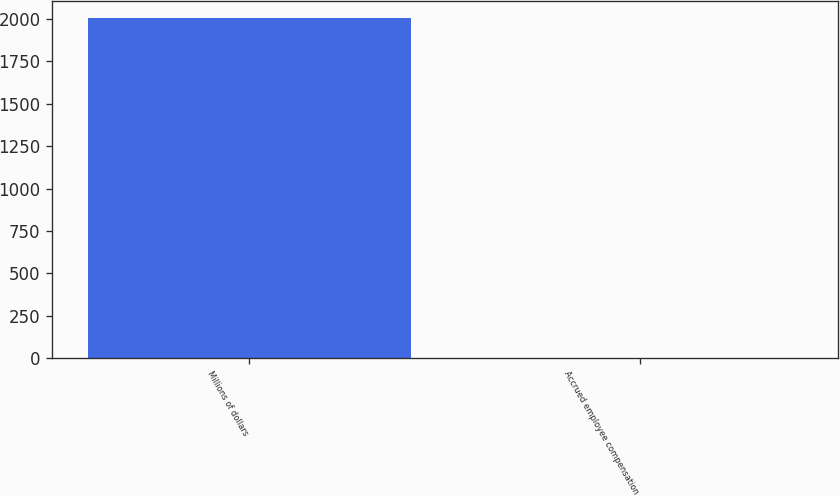Convert chart to OTSL. <chart><loc_0><loc_0><loc_500><loc_500><bar_chart><fcel>Millions of dollars<fcel>Accrued employee compensation<nl><fcel>2007<fcel>1<nl></chart> 